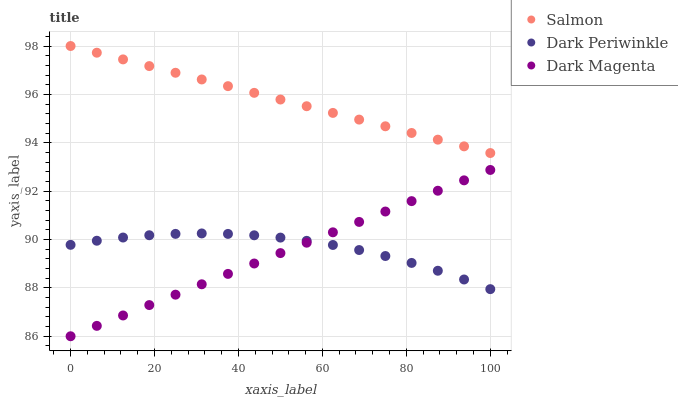Does Dark Magenta have the minimum area under the curve?
Answer yes or no. Yes. Does Salmon have the maximum area under the curve?
Answer yes or no. Yes. Does Dark Periwinkle have the minimum area under the curve?
Answer yes or no. No. Does Dark Periwinkle have the maximum area under the curve?
Answer yes or no. No. Is Salmon the smoothest?
Answer yes or no. Yes. Is Dark Periwinkle the roughest?
Answer yes or no. Yes. Is Dark Magenta the smoothest?
Answer yes or no. No. Is Dark Magenta the roughest?
Answer yes or no. No. Does Dark Magenta have the lowest value?
Answer yes or no. Yes. Does Dark Periwinkle have the lowest value?
Answer yes or no. No. Does Salmon have the highest value?
Answer yes or no. Yes. Does Dark Magenta have the highest value?
Answer yes or no. No. Is Dark Magenta less than Salmon?
Answer yes or no. Yes. Is Salmon greater than Dark Magenta?
Answer yes or no. Yes. Does Dark Periwinkle intersect Dark Magenta?
Answer yes or no. Yes. Is Dark Periwinkle less than Dark Magenta?
Answer yes or no. No. Is Dark Periwinkle greater than Dark Magenta?
Answer yes or no. No. Does Dark Magenta intersect Salmon?
Answer yes or no. No. 